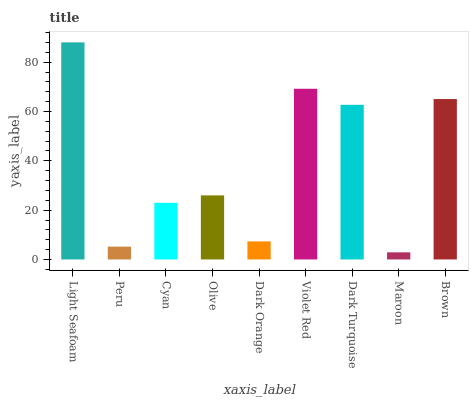Is Maroon the minimum?
Answer yes or no. Yes. Is Light Seafoam the maximum?
Answer yes or no. Yes. Is Peru the minimum?
Answer yes or no. No. Is Peru the maximum?
Answer yes or no. No. Is Light Seafoam greater than Peru?
Answer yes or no. Yes. Is Peru less than Light Seafoam?
Answer yes or no. Yes. Is Peru greater than Light Seafoam?
Answer yes or no. No. Is Light Seafoam less than Peru?
Answer yes or no. No. Is Olive the high median?
Answer yes or no. Yes. Is Olive the low median?
Answer yes or no. Yes. Is Cyan the high median?
Answer yes or no. No. Is Dark Turquoise the low median?
Answer yes or no. No. 